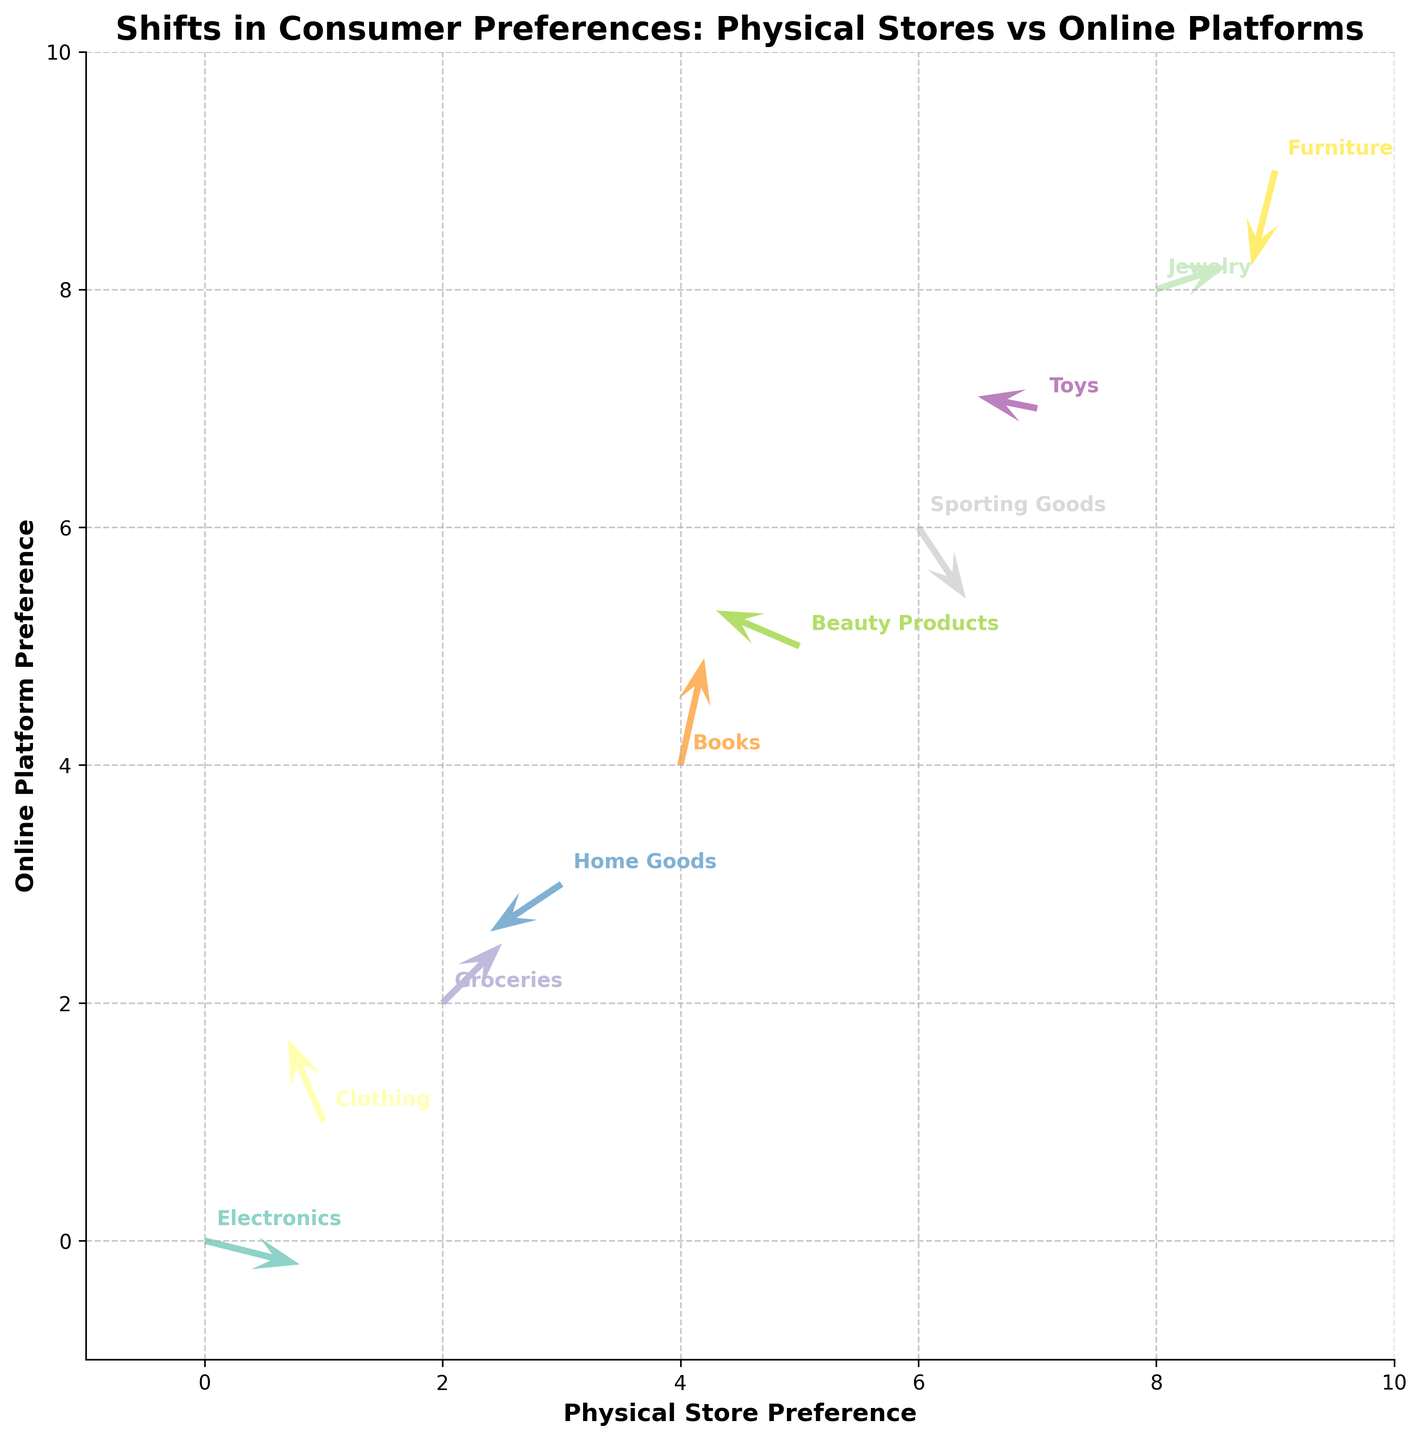What's the title of the figure? The title of a figure is usually positioned at the top, in a larger and bolder font than other text on the plot. In this case, the title explicitly states what the plot is about.
Answer: Shifts in Consumer Preferences: Physical Stores vs Online Platforms How many categories of data points are represented in the plot? Each category in the data corresponds to a different row and is visually differentiated by color and text labeling on the figure. By counting these distinct labels, you can determine the number of represented categories.
Answer: 10 Which category experiences the largest positive shift towards online platforms? A positive shift towards online platforms corresponds to a positive y-component (v) of the vector. Comparing all the y-components visually, the one with the largest positive value is identified.
Answer: Books How does the preference shift for Home Goods compare to that for Electronics? To compare, observe the direction and size of the vectors for Home Goods and Electronics. Home Goods shows a negative shift in both x (towards physical stores) and y (away from online platforms), while Electronics shows a positive shift in x and a slight negative in y.
Answer: Home Goods shifts more towards physical stores and away from online, while Electronics shifts slightly towards physical stores and less away from online What is the overall trend in purchasing behaviors for Clothing? Analyze the direction and magnitude of the vector originating from the Clothing data point. The vector has a negative x-component and a positive y-component, indicating a shift from physical stores to online platforms.
Answer: From physical stores to online platforms Which category shows the smallest net shift in consumer preference? Calculate net shifts by combining the magnitudes of the x and y components of each category's vector. The smallest displacement vector, considering both directions, will indicate the smallest net shift.
Answer: Toys Are there any categories that show a decrease in both physical store and online platform preferences? This situation is represented by vectors with negative x and y components. Observing these components for each category identifies the relevant data points.
Answer: Furniture and Home Goods Which categories have a shift vector that moves upward from left to right? Upward and rightward movement corresponds to positive u (x-component) and v (y-component). Check the vectors visually to determine which meet this criterion.
Answer: Groceries and Jewelry What might be implied about consumer preferences if a category's vector has a negative x-component but a positive y-component? A negative x-component and a positive y-component indicate a decrease in preference for physical stores coupled with an increase in preference for online platforms. This represents a shift from physical to online shopping for that category.
Answer: Shift from physical stores to online platforms 